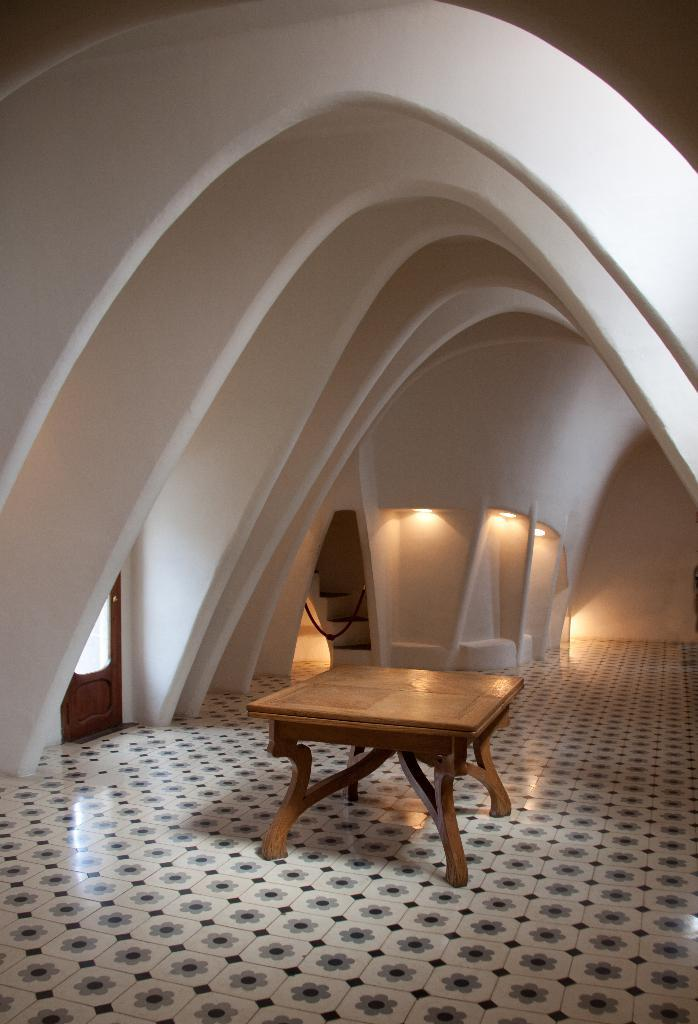What type of furniture is present in the image? There is a table in the image. What is located above the table? There is an architecture wall above the table. Where is the door situated in the image? The door is in the left corner of the image. Can you describe any other objects visible in the background of the image? There are other objects visible in the background of the image, but their specific details are not provided. What type of whistle can be heard in the image? There is no whistle present in the image, and therefore no sound can be heard. Is there a carpenter working on the architecture wall in the image? There is no indication of a carpenter or any work being done on the architecture wall in the image. 